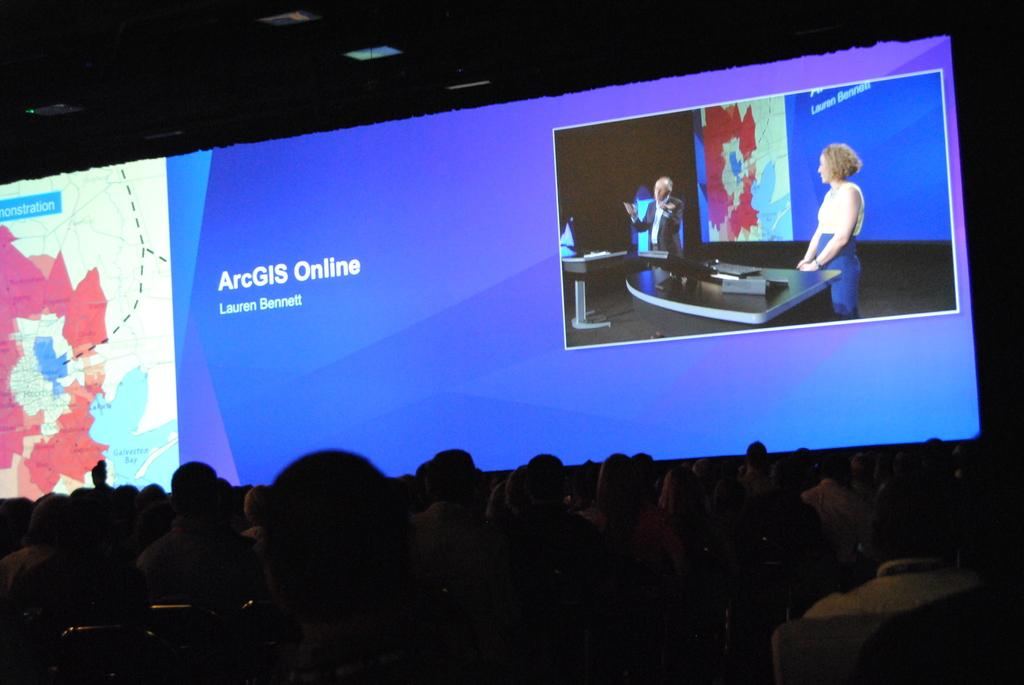<image>
Summarize the visual content of the image. an arcGis name that is in front of a blue background 